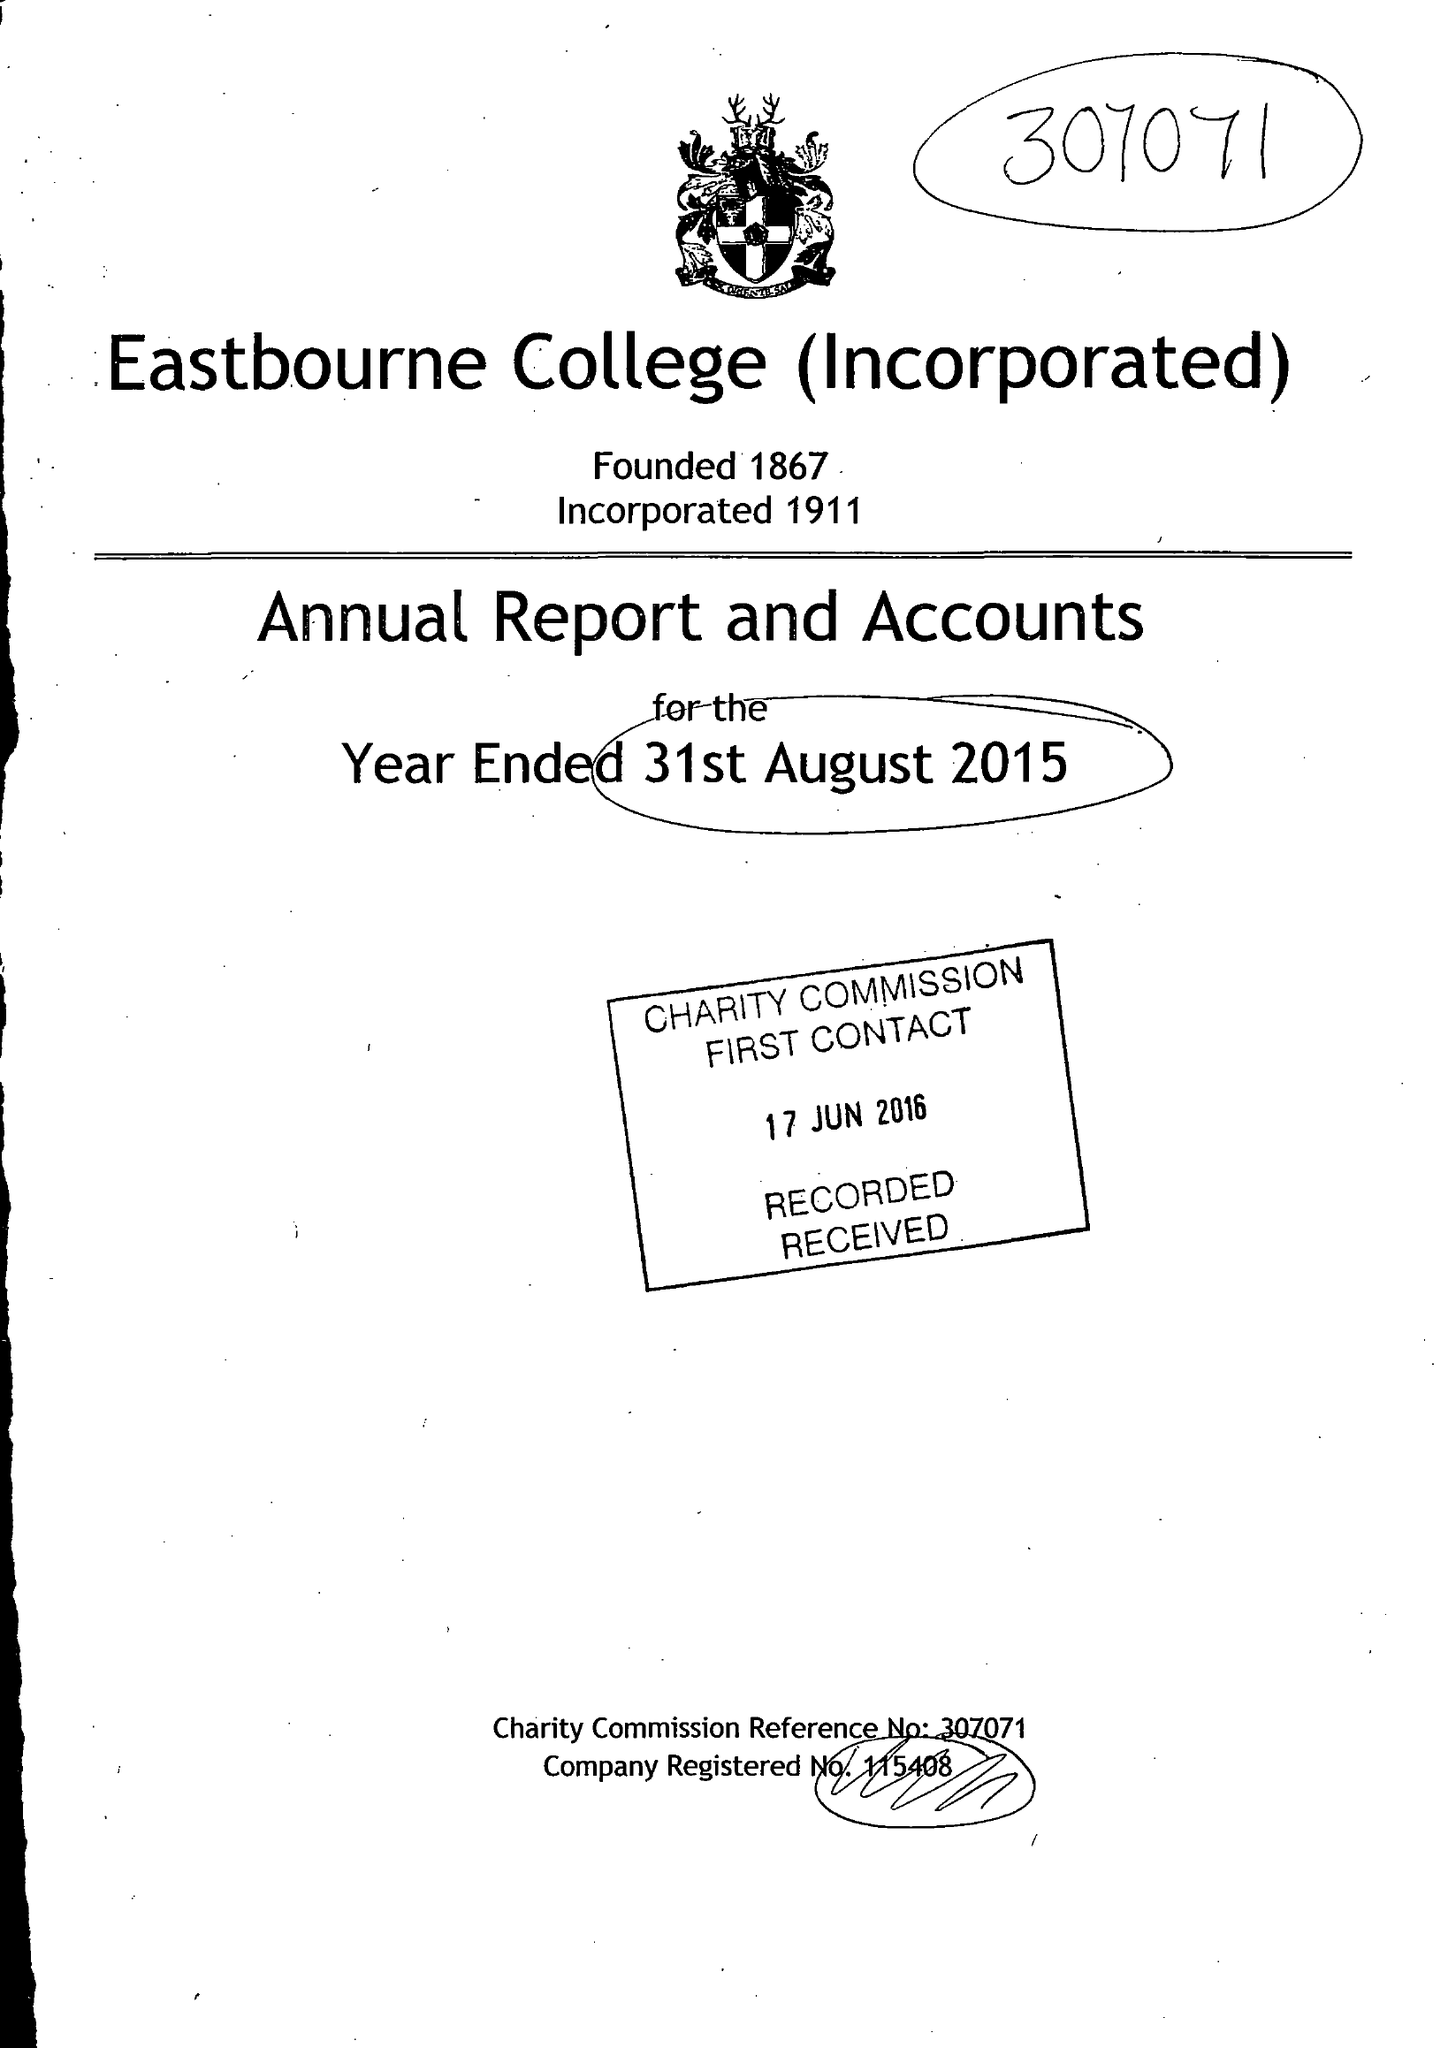What is the value for the address__post_town?
Answer the question using a single word or phrase. EASTBOURNE 